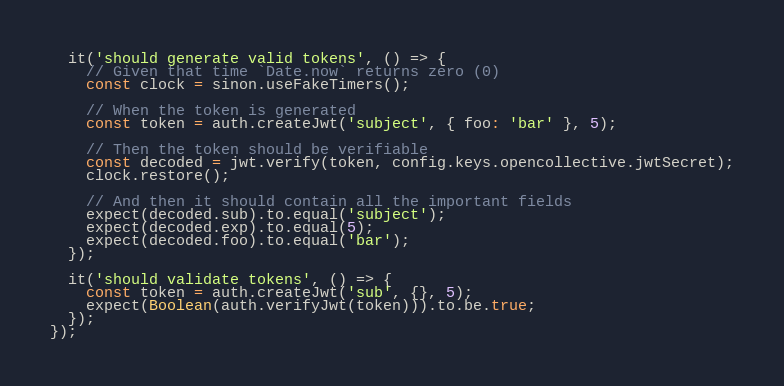<code> <loc_0><loc_0><loc_500><loc_500><_JavaScript_>  it('should generate valid tokens', () => {
    // Given that time `Date.now` returns zero (0)
    const clock = sinon.useFakeTimers();

    // When the token is generated
    const token = auth.createJwt('subject', { foo: 'bar' }, 5);

    // Then the token should be verifiable
    const decoded = jwt.verify(token, config.keys.opencollective.jwtSecret);
    clock.restore();

    // And then it should contain all the important fields
    expect(decoded.sub).to.equal('subject');
    expect(decoded.exp).to.equal(5);
    expect(decoded.foo).to.equal('bar');
  });

  it('should validate tokens', () => {
    const token = auth.createJwt('sub', {}, 5);
    expect(Boolean(auth.verifyJwt(token))).to.be.true;
  });
});
</code> 